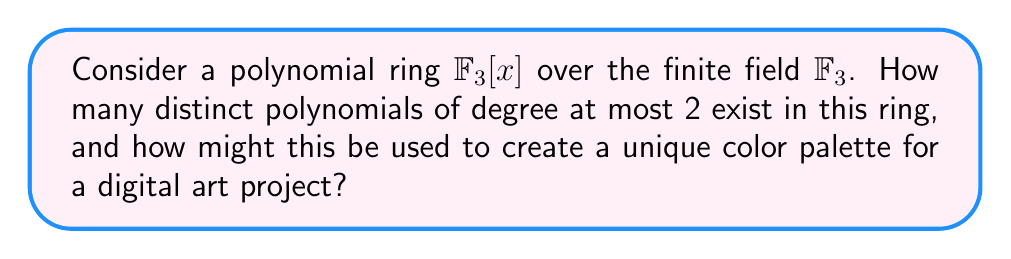Give your solution to this math problem. To solve this problem, let's break it down into steps:

1) First, recall that $\mathbb{F}_3$ is the finite field with 3 elements: {0, 1, 2}.

2) A polynomial of degree at most 2 in $\mathbb{F}_3[x]$ has the general form:

   $ax^2 + bx + c$, where $a, b, c \in \mathbb{F}_3$

3) Let's count the possibilities for each coefficient:
   - $a$ can be 0, 1, or 2 (3 choices)
   - $b$ can be 0, 1, or 2 (3 choices)
   - $c$ can be 0, 1, or 2 (3 choices)

4) By the multiplication principle, the total number of distinct polynomials is:

   $3 \times 3 \times 3 = 27$

5) For the digital art application, we can map these 27 polynomials to a unique color palette. Here's one way to do it:

   - Use the coefficients $(a,b,c)$ as RGB color values
   - Scale these values to the standard 0-255 range by multiplying by 85 (as $2 \times 85 = 170$ and $3 \times 85 = 255$)

6) This gives us a palette of 27 distinct colors, each corresponding to a unique polynomial in $\mathbb{F}_3[x]$ of degree at most 2.

7) For a provocative digital art project, you could use these colors to create abstract patterns or images where each pixel's color represents a polynomial. The mathematical structure underlying the colors adds an intriguing layer of complexity to the artwork.
Answer: There are 27 distinct polynomials of degree at most 2 in $\mathbb{F}_3[x]$. These can be used to create a unique 27-color palette for digital art by mapping the coefficients to RGB values. 